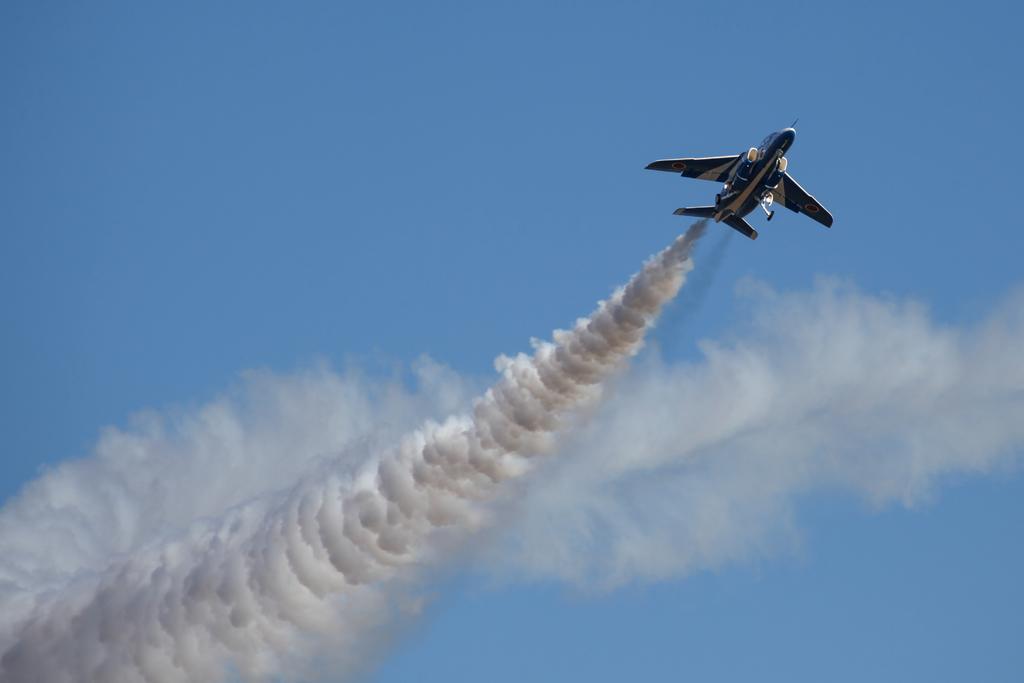Can you describe this image briefly? In this image I can see an aircraft flying in air. I can see the smoke and blue color sky. 